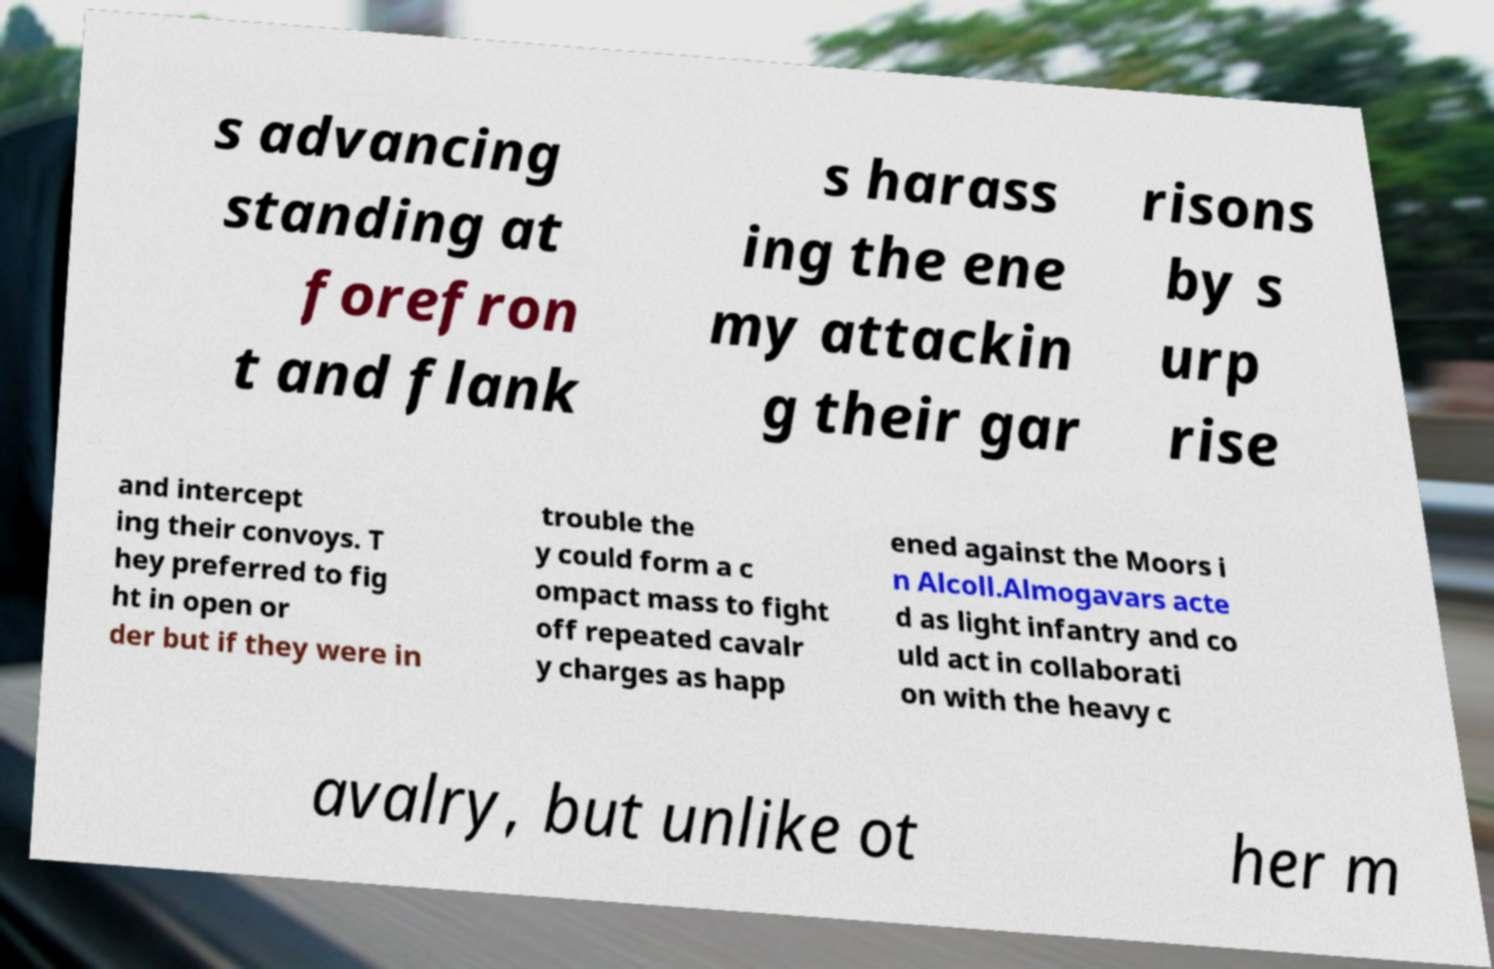Could you extract and type out the text from this image? s advancing standing at forefron t and flank s harass ing the ene my attackin g their gar risons by s urp rise and intercept ing their convoys. T hey preferred to fig ht in open or der but if they were in trouble the y could form a c ompact mass to fight off repeated cavalr y charges as happ ened against the Moors i n Alcoll.Almogavars acte d as light infantry and co uld act in collaborati on with the heavy c avalry, but unlike ot her m 